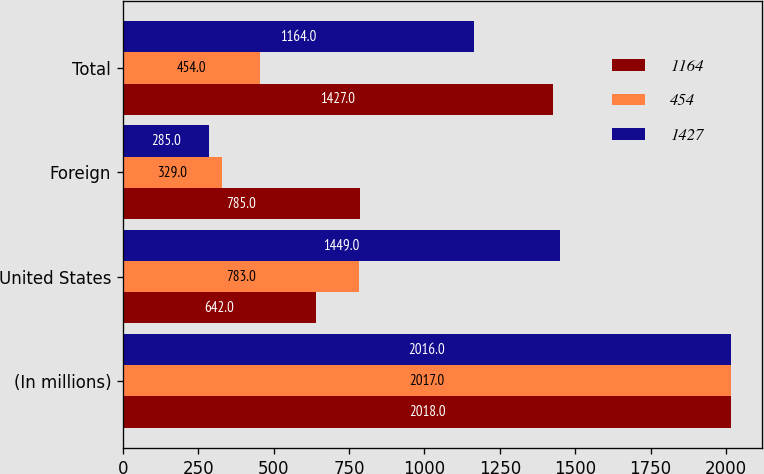Convert chart. <chart><loc_0><loc_0><loc_500><loc_500><stacked_bar_chart><ecel><fcel>(In millions)<fcel>United States<fcel>Foreign<fcel>Total<nl><fcel>1164<fcel>2018<fcel>642<fcel>785<fcel>1427<nl><fcel>454<fcel>2017<fcel>783<fcel>329<fcel>454<nl><fcel>1427<fcel>2016<fcel>1449<fcel>285<fcel>1164<nl></chart> 